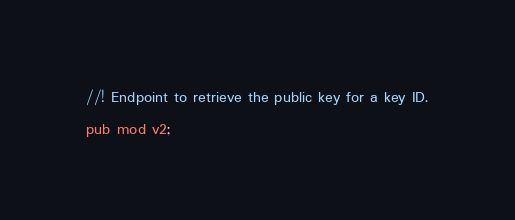<code> <loc_0><loc_0><loc_500><loc_500><_Rust_>//! Endpoint to retrieve the public key for a key ID.

pub mod v2;
</code> 